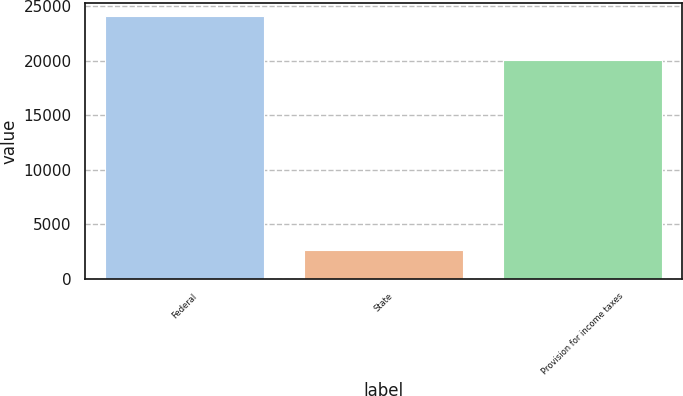Convert chart. <chart><loc_0><loc_0><loc_500><loc_500><bar_chart><fcel>Federal<fcel>State<fcel>Provision for income taxes<nl><fcel>24083<fcel>2630<fcel>20108<nl></chart> 